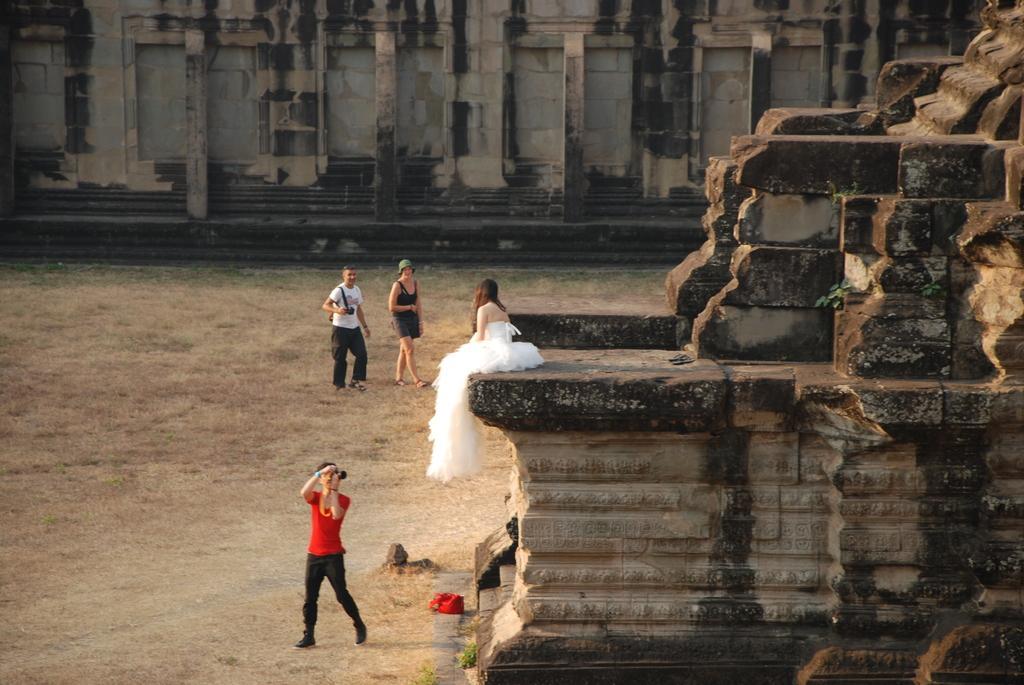Please provide a concise description of this image. In the foreground of the picture we can see people, an old construction, grass, bag and soil. In the background there is a wall. 